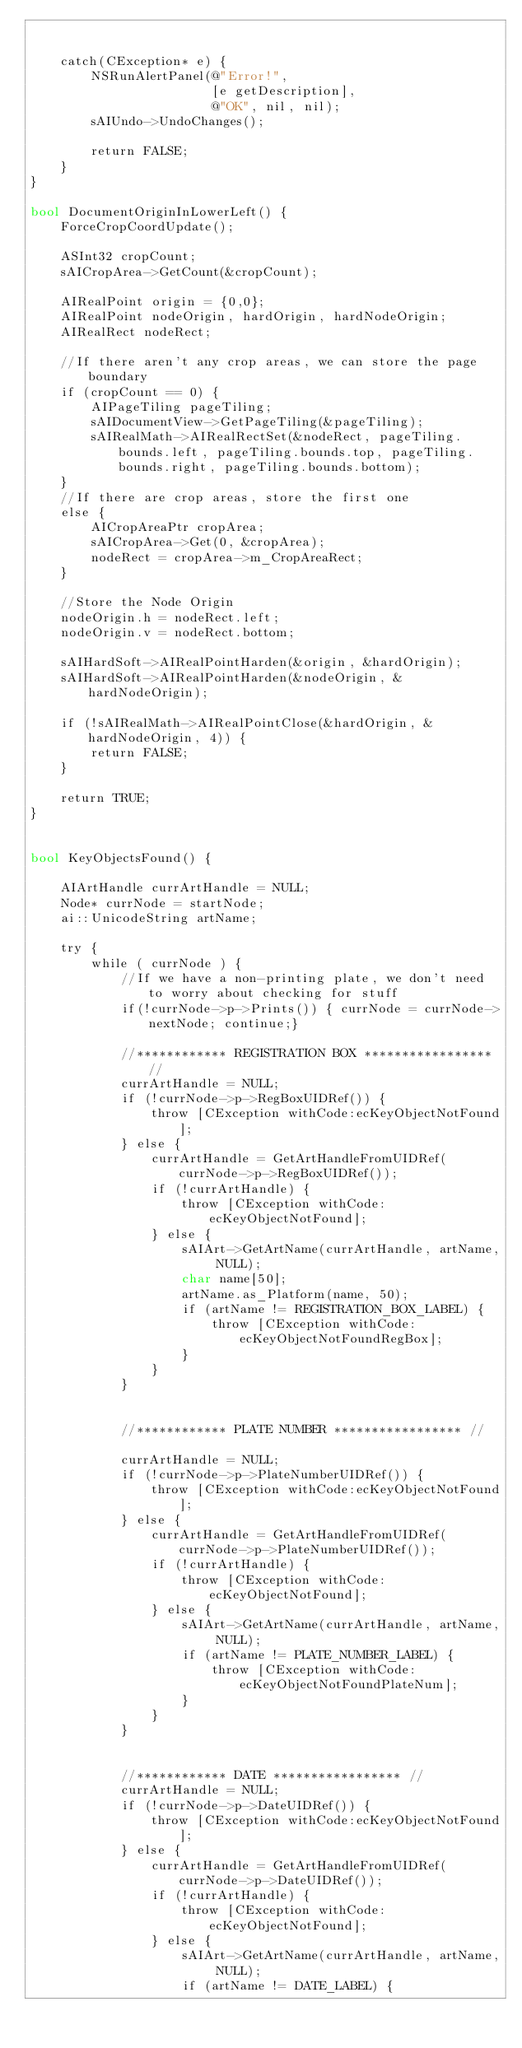<code> <loc_0><loc_0><loc_500><loc_500><_ObjectiveC_>	
	
	catch(CException* e) {
		NSRunAlertPanel(@"Error!", 
                        [e getDescription],
                        @"OK", nil, nil);
		sAIUndo->UndoChanges();
		
		return FALSE;
	}
}

bool DocumentOriginInLowerLeft() {
	ForceCropCoordUpdate();
	
	ASInt32 cropCount;
	sAICropArea->GetCount(&cropCount);
	
	AIRealPoint origin = {0,0};
	AIRealPoint nodeOrigin, hardOrigin, hardNodeOrigin;
	AIRealRect nodeRect;
	
	//If there aren't any crop areas, we can store the page boundary
	if (cropCount == 0) {
		AIPageTiling pageTiling;
		sAIDocumentView->GetPageTiling(&pageTiling);
		sAIRealMath->AIRealRectSet(&nodeRect, pageTiling.bounds.left, pageTiling.bounds.top, pageTiling.bounds.right, pageTiling.bounds.bottom);
	}
	//If there are crop areas, store the first one
	else {
		AICropAreaPtr cropArea;
		sAICropArea->Get(0, &cropArea);
		nodeRect = cropArea->m_CropAreaRect;
	}
	
	//Store the Node Origin
	nodeOrigin.h = nodeRect.left;
	nodeOrigin.v = nodeRect.bottom;
	
	sAIHardSoft->AIRealPointHarden(&origin, &hardOrigin);
	sAIHardSoft->AIRealPointHarden(&nodeOrigin, &hardNodeOrigin);
	
	if (!sAIRealMath->AIRealPointClose(&hardOrigin, &hardNodeOrigin, 4)) {
		return FALSE;
	}
	
	return TRUE;
}


bool KeyObjectsFound() {
	
	AIArtHandle currArtHandle = NULL;
	Node* currNode = startNode;
	ai::UnicodeString artName;
	
	try {
		while ( currNode ) {
			//If we have a non-printing plate, we don't need to worry about checking for stuff
			if(!currNode->p->Prints()) { currNode = currNode->nextNode; continue;}
			
			//************ REGISTRATION BOX ***************** //
			currArtHandle = NULL;
			if (!currNode->p->RegBoxUIDRef()) {
				throw [CException withCode:ecKeyObjectNotFound];		
			} else {
				currArtHandle = GetArtHandleFromUIDRef(currNode->p->RegBoxUIDRef());
				if (!currArtHandle) {
					throw [CException withCode:ecKeyObjectNotFound];
				} else {
					sAIArt->GetArtName(currArtHandle, artName, NULL);
					char name[50];
					artName.as_Platform(name, 50);
					if (artName != REGISTRATION_BOX_LABEL) {
						throw [CException withCode:ecKeyObjectNotFoundRegBox];
					}
				}
			}
			
			
			//************ PLATE NUMBER ***************** //	
			currArtHandle = NULL;
			if (!currNode->p->PlateNumberUIDRef()) {
				throw [CException withCode:ecKeyObjectNotFound];		
			} else {
				currArtHandle = GetArtHandleFromUIDRef(currNode->p->PlateNumberUIDRef());
				if (!currArtHandle) {
					throw [CException withCode:ecKeyObjectNotFound];
				} else {
					sAIArt->GetArtName(currArtHandle, artName, NULL);
					if (artName != PLATE_NUMBER_LABEL) {
						throw [CException withCode:ecKeyObjectNotFoundPlateNum];
					}
				}
			}
			
			
			//************ DATE ***************** //	
			currArtHandle = NULL;
			if (!currNode->p->DateUIDRef()) {
				throw [CException withCode:ecKeyObjectNotFound];		
			} else {
				currArtHandle = GetArtHandleFromUIDRef(currNode->p->DateUIDRef());
				if (!currArtHandle) {
					throw [CException withCode:ecKeyObjectNotFound];
				} else {
					sAIArt->GetArtName(currArtHandle, artName, NULL);
					if (artName != DATE_LABEL) {</code> 